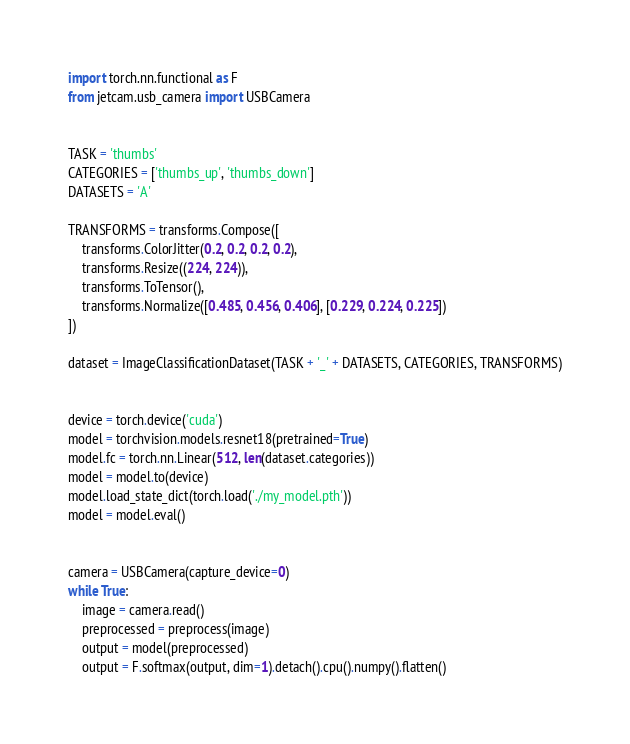<code> <loc_0><loc_0><loc_500><loc_500><_Python_>import torch.nn.functional as F
from jetcam.usb_camera import USBCamera


TASK = 'thumbs'
CATEGORIES = ['thumbs_up', 'thumbs_down']
DATASETS = 'A'

TRANSFORMS = transforms.Compose([
    transforms.ColorJitter(0.2, 0.2, 0.2, 0.2),
    transforms.Resize((224, 224)),
    transforms.ToTensor(),
    transforms.Normalize([0.485, 0.456, 0.406], [0.229, 0.224, 0.225])
])

dataset = ImageClassificationDataset(TASK + '_' + DATASETS, CATEGORIES, TRANSFORMS)


device = torch.device('cuda')
model = torchvision.models.resnet18(pretrained=True)
model.fc = torch.nn.Linear(512, len(dataset.categories))
model = model.to(device)
model.load_state_dict(torch.load('./my_model.pth'))
model = model.eval()


camera = USBCamera(capture_device=0)
while True:
    image = camera.read()
    preprocessed = preprocess(image)
    output = model(preprocessed)
    output = F.softmax(output, dim=1).detach().cpu().numpy().flatten()</code> 